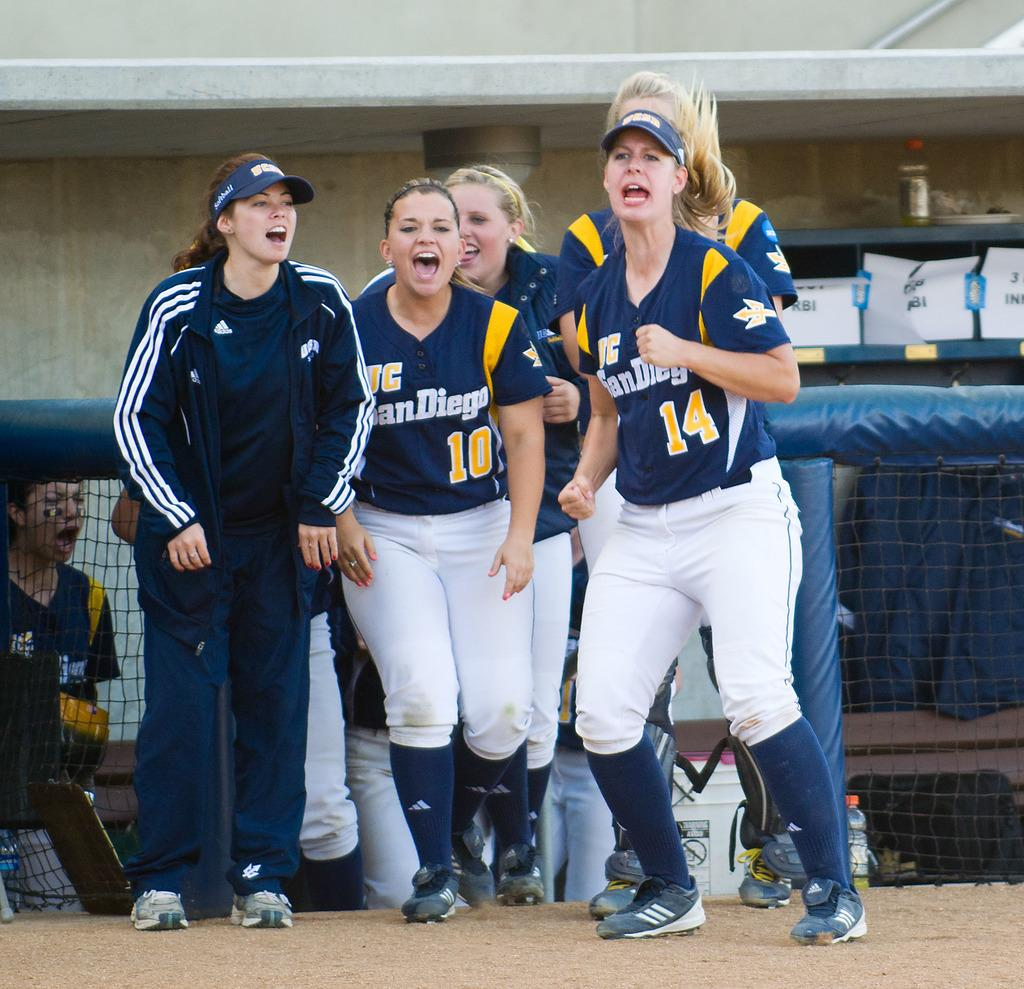<image>
Share a concise interpretation of the image provided. A group of women in San Diego jerseys cheer. 